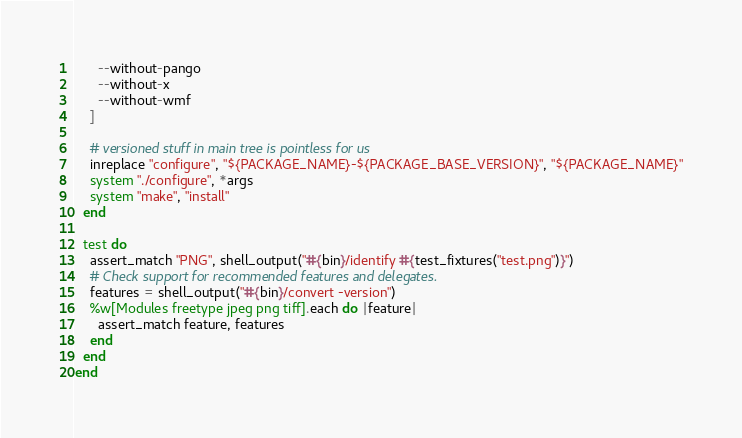<code> <loc_0><loc_0><loc_500><loc_500><_Ruby_>      --without-pango
      --without-x
      --without-wmf
    ]

    # versioned stuff in main tree is pointless for us
    inreplace "configure", "${PACKAGE_NAME}-${PACKAGE_BASE_VERSION}", "${PACKAGE_NAME}"
    system "./configure", *args
    system "make", "install"
  end

  test do
    assert_match "PNG", shell_output("#{bin}/identify #{test_fixtures("test.png")}")
    # Check support for recommended features and delegates.
    features = shell_output("#{bin}/convert -version")
    %w[Modules freetype jpeg png tiff].each do |feature|
      assert_match feature, features
    end
  end
end
</code> 